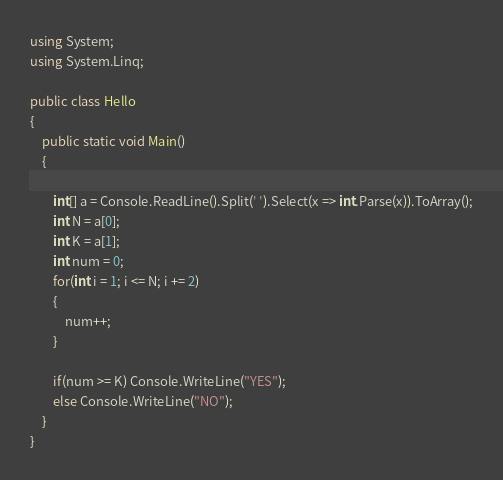Convert code to text. <code><loc_0><loc_0><loc_500><loc_500><_C#_>using System;
using System.Linq;

public class Hello
{
    public static void Main()
    {
       
        int[] a = Console.ReadLine().Split(' ').Select(x => int.Parse(x)).ToArray();
        int N = a[0];
        int K = a[1];
        int num = 0;
        for(int i = 1; i <= N; i += 2)
        {
            num++;
        }
        
        if(num >= K) Console.WriteLine("YES");
        else Console.WriteLine("NO");
    }
}</code> 